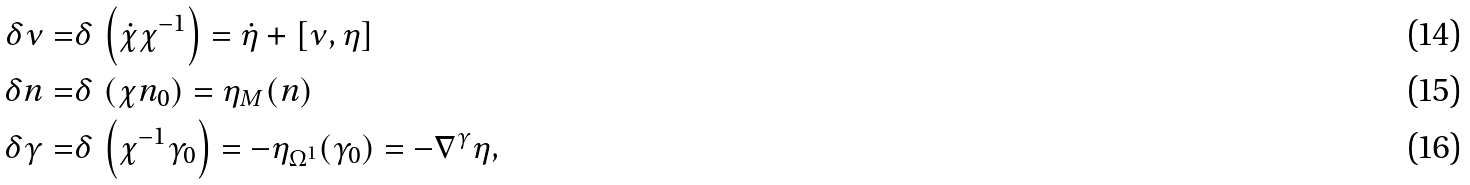Convert formula to latex. <formula><loc_0><loc_0><loc_500><loc_500>\delta \nu = & \delta \, \left ( \dot { \chi } \chi ^ { - 1 } \right ) = \dot { \eta } + \left [ \nu , \eta \right ] \\ \delta n = & \delta \, \left ( \chi n _ { 0 } \right ) = \eta _ { M } ( n ) \\ \delta \gamma = & \delta \, \left ( \chi ^ { - 1 } \gamma _ { 0 } \right ) = - \eta _ { \Omega ^ { 1 } } ( \gamma _ { 0 } ) = - { \nabla } ^ { \gamma } \eta ,</formula> 